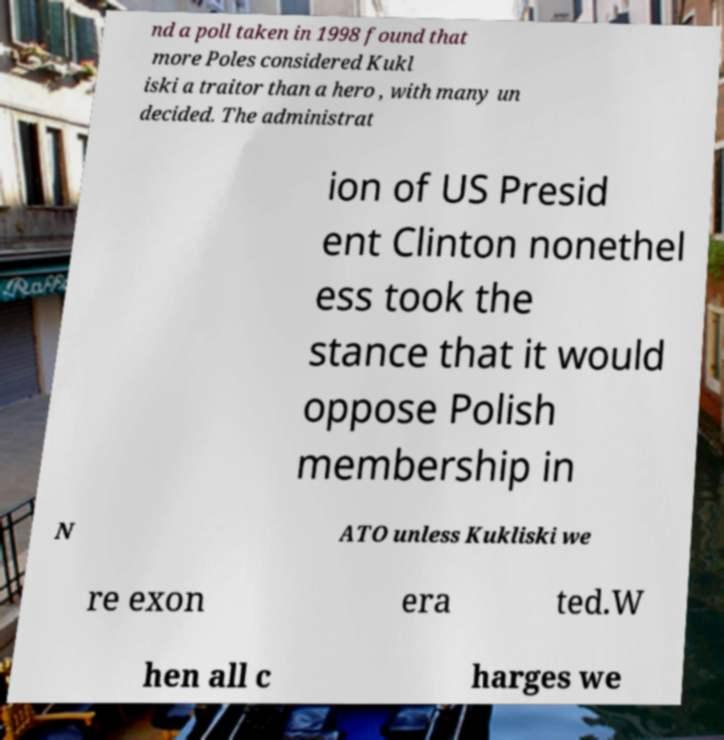There's text embedded in this image that I need extracted. Can you transcribe it verbatim? nd a poll taken in 1998 found that more Poles considered Kukl iski a traitor than a hero , with many un decided. The administrat ion of US Presid ent Clinton nonethel ess took the stance that it would oppose Polish membership in N ATO unless Kukliski we re exon era ted.W hen all c harges we 